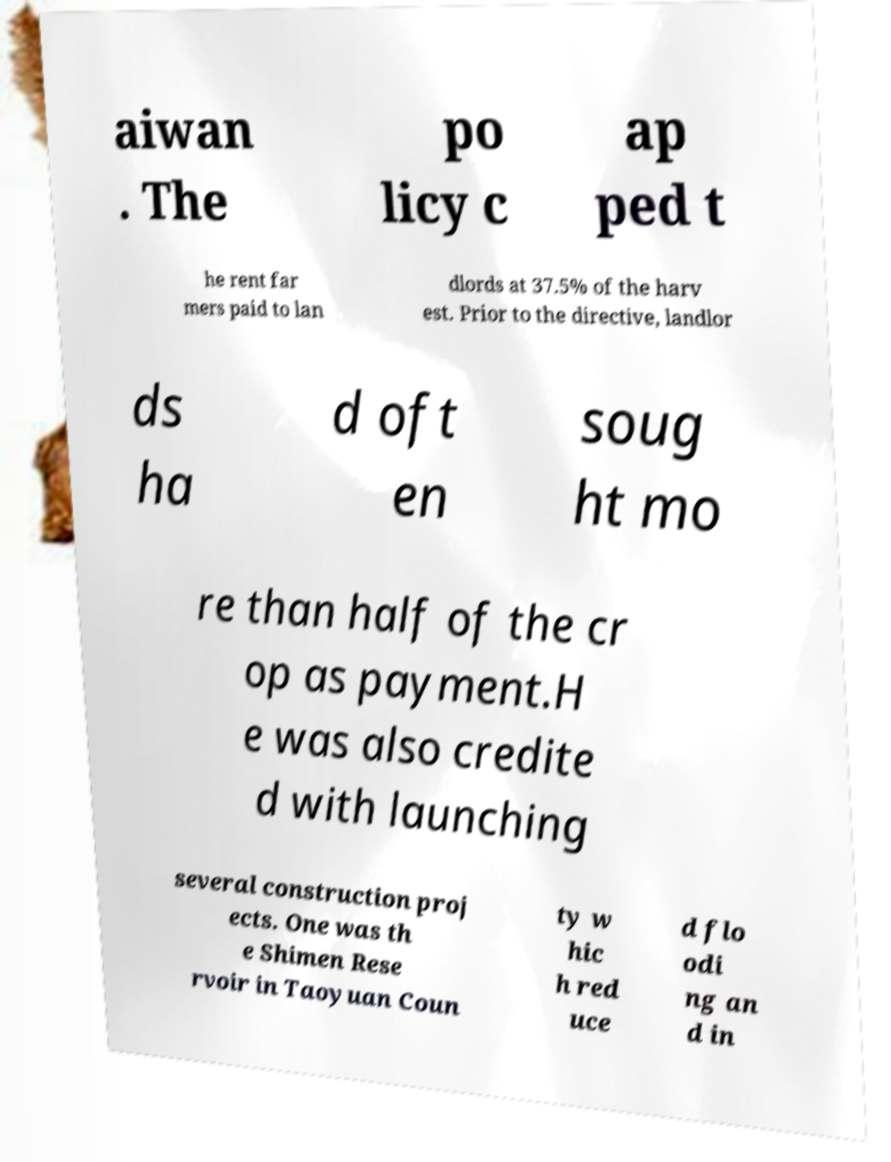I need the written content from this picture converted into text. Can you do that? aiwan . The po licy c ap ped t he rent far mers paid to lan dlords at 37.5% of the harv est. Prior to the directive, landlor ds ha d oft en soug ht mo re than half of the cr op as payment.H e was also credite d with launching several construction proj ects. One was th e Shimen Rese rvoir in Taoyuan Coun ty w hic h red uce d flo odi ng an d in 